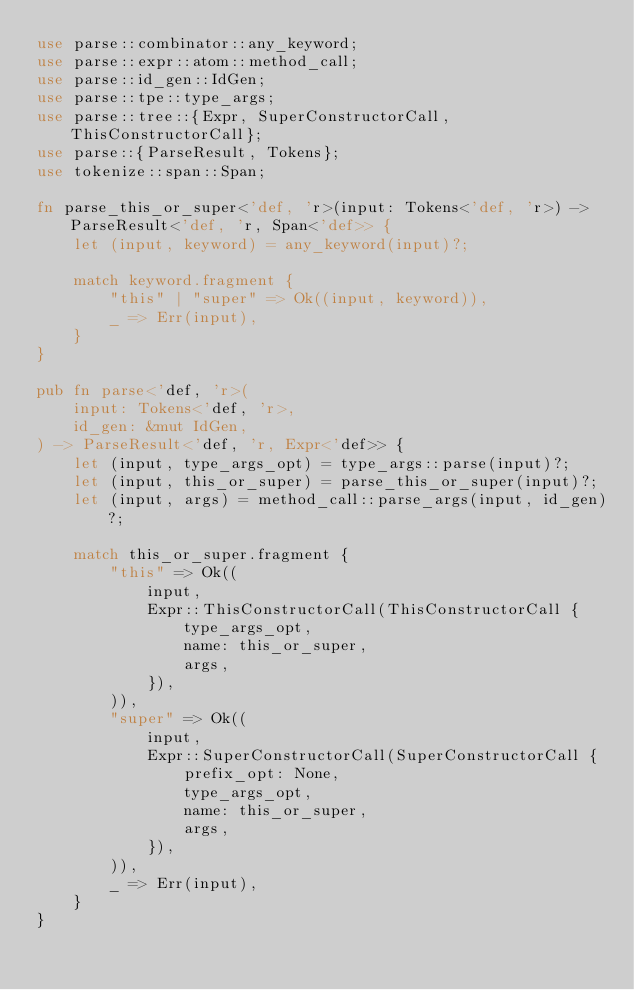Convert code to text. <code><loc_0><loc_0><loc_500><loc_500><_Rust_>use parse::combinator::any_keyword;
use parse::expr::atom::method_call;
use parse::id_gen::IdGen;
use parse::tpe::type_args;
use parse::tree::{Expr, SuperConstructorCall, ThisConstructorCall};
use parse::{ParseResult, Tokens};
use tokenize::span::Span;

fn parse_this_or_super<'def, 'r>(input: Tokens<'def, 'r>) -> ParseResult<'def, 'r, Span<'def>> {
    let (input, keyword) = any_keyword(input)?;

    match keyword.fragment {
        "this" | "super" => Ok((input, keyword)),
        _ => Err(input),
    }
}

pub fn parse<'def, 'r>(
    input: Tokens<'def, 'r>,
    id_gen: &mut IdGen,
) -> ParseResult<'def, 'r, Expr<'def>> {
    let (input, type_args_opt) = type_args::parse(input)?;
    let (input, this_or_super) = parse_this_or_super(input)?;
    let (input, args) = method_call::parse_args(input, id_gen)?;

    match this_or_super.fragment {
        "this" => Ok((
            input,
            Expr::ThisConstructorCall(ThisConstructorCall {
                type_args_opt,
                name: this_or_super,
                args,
            }),
        )),
        "super" => Ok((
            input,
            Expr::SuperConstructorCall(SuperConstructorCall {
                prefix_opt: None,
                type_args_opt,
                name: this_or_super,
                args,
            }),
        )),
        _ => Err(input),
    }
}
</code> 